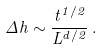<formula> <loc_0><loc_0><loc_500><loc_500>\Delta h \sim \frac { t ^ { 1 / 2 } } { L ^ { d / 2 } } \, .</formula> 